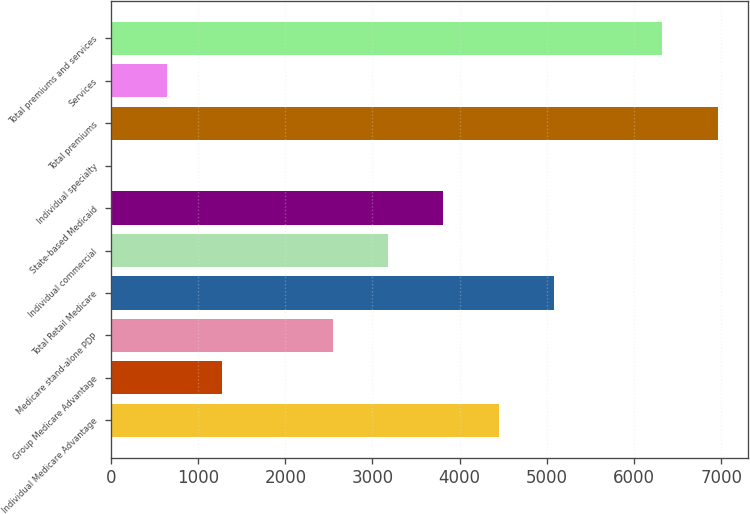Convert chart. <chart><loc_0><loc_0><loc_500><loc_500><bar_chart><fcel>Individual Medicare Advantage<fcel>Group Medicare Advantage<fcel>Medicare stand-alone PDP<fcel>Total Retail Medicare<fcel>Individual commercial<fcel>State-based Medicaid<fcel>Individual specialty<fcel>Total premiums<fcel>Services<fcel>Total premiums and services<nl><fcel>4448.6<fcel>1274.6<fcel>2544.2<fcel>5083.4<fcel>3179<fcel>3813.8<fcel>5<fcel>6957.8<fcel>639.8<fcel>6323<nl></chart> 